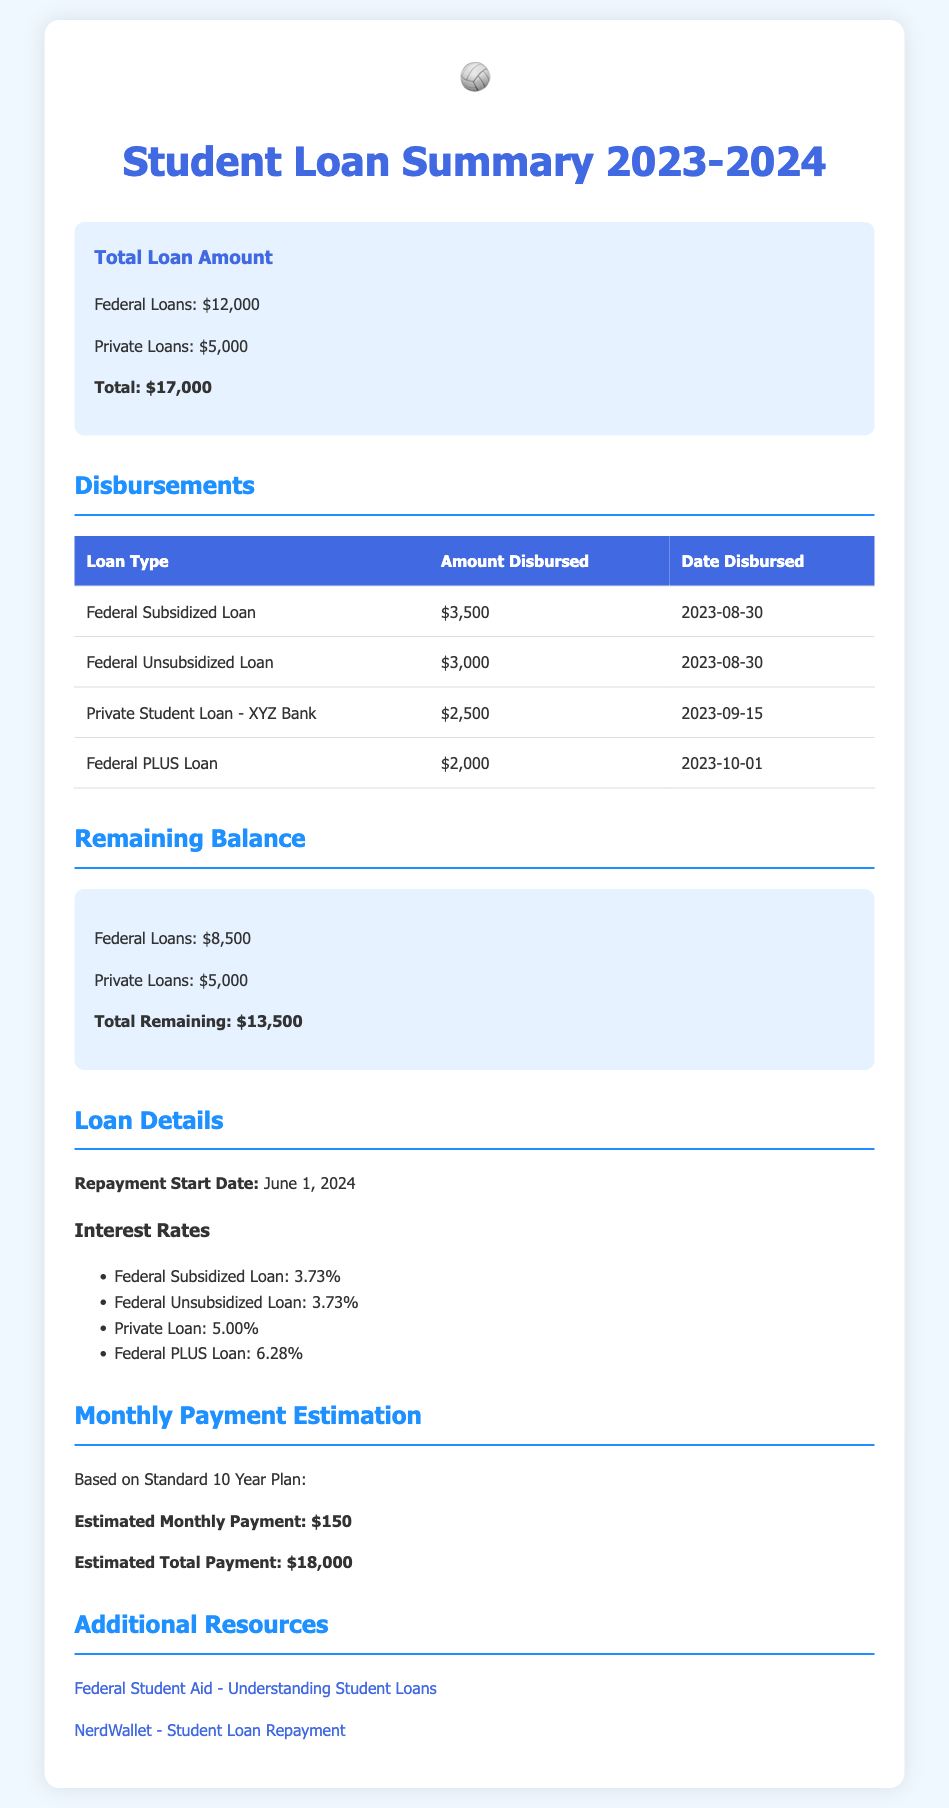What is the total student loan amount? The total student loan amount is the sum of federal and private loans listed in the document, which is $12,000 + $5,000.
Answer: $17,000 When was the Federal Unsubsidized Loan disbursed? The date when the Federal Unsubsidized Loan was disbursed can be found in the disbursements table, which is 2023-08-30.
Answer: 2023-08-30 How much is the remaining balance for Federal Loans? The remaining balance for Federal Loans is provided in the summary section, which states it is $8,500.
Answer: $8,500 What is the interest rate for Private Loans? The interest rate for Private Loans is specifically listed under Interest Rates, which is 5.00%.
Answer: 5.00% What is the estimated total payment based on the Standard 10 Year Plan? The estimated total payment is calculated as part of the monthly payment estimation section, which states it is $18,000.
Answer: $18,000 What type of loan has the highest interest rate? To find the loan with the highest interest rate, compare the rates mentioned for each loan type, and the Federal PLUS Loan has the highest at 6.28%.
Answer: Federal PLUS Loan What is the repayment start date for the loans? The repayment start date for the loans is provided in the document, specifically stating it is June 1, 2024.
Answer: June 1, 2024 How much was disbursed for the Federal Subsidized Loan? The disbursed amount for the Federal Subsidized Loan is listed in the disbursements table, which shows $3,500.
Answer: $3,500 How many different types of loans are mentioned in the summary? To identify the types of loans mentioned, count each one listed in the document, and there are a total of four types of loans.
Answer: Four 